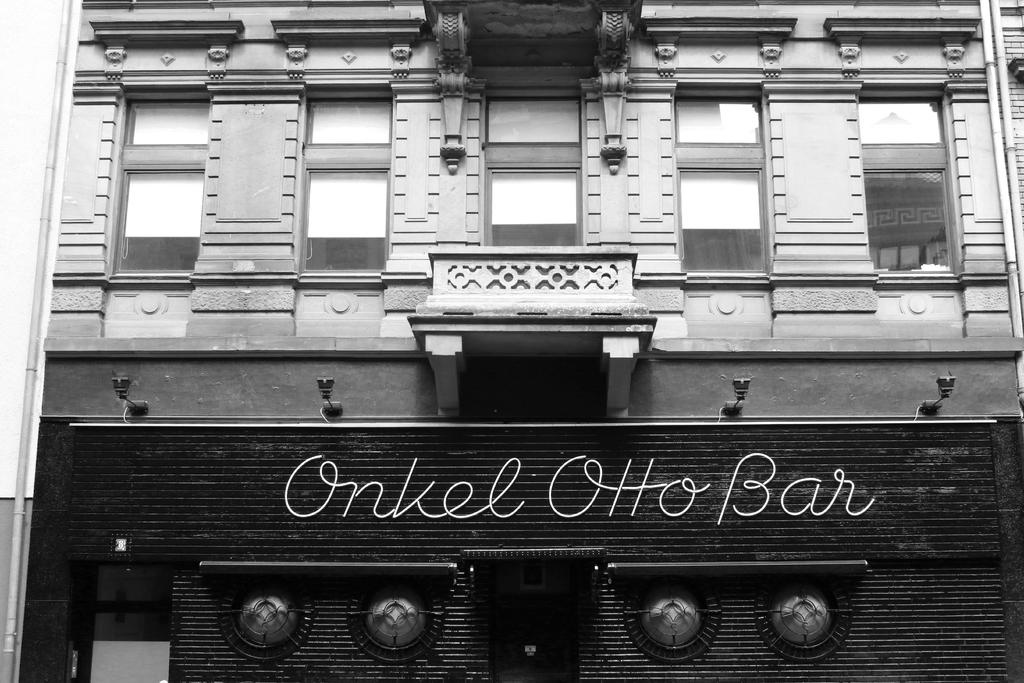What is the main subject of the image? The main subject of the image is a building. What can be found at the bottom of the image? There is text at the bottom of the image. What features can be observed on the building? The building has windows, glasses, and walls. What type of surprise or shock is depicted in the image? There is no surprise or shock depicted in the image; it features a building with text, windows, glasses, and walls. Is there a party happening in the image? There is: There is no indication of a party in the image; it focuses on a building with text and various features. 